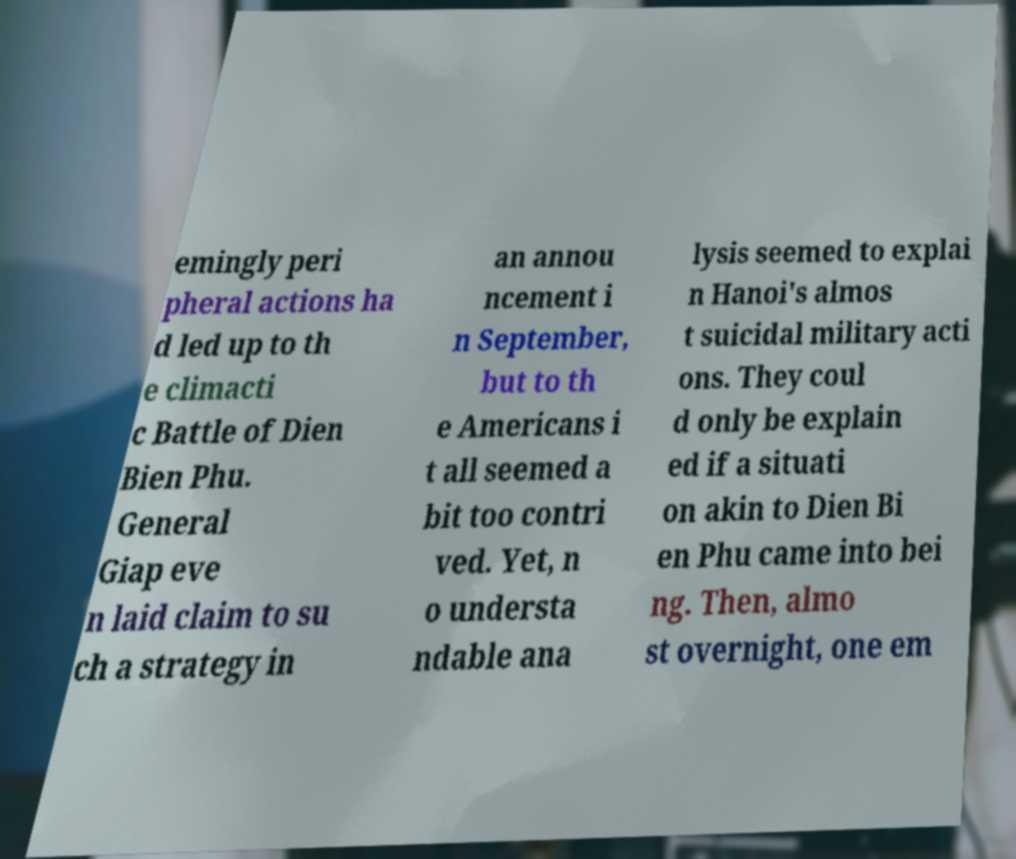I need the written content from this picture converted into text. Can you do that? emingly peri pheral actions ha d led up to th e climacti c Battle of Dien Bien Phu. General Giap eve n laid claim to su ch a strategy in an annou ncement i n September, but to th e Americans i t all seemed a bit too contri ved. Yet, n o understa ndable ana lysis seemed to explai n Hanoi's almos t suicidal military acti ons. They coul d only be explain ed if a situati on akin to Dien Bi en Phu came into bei ng. Then, almo st overnight, one em 